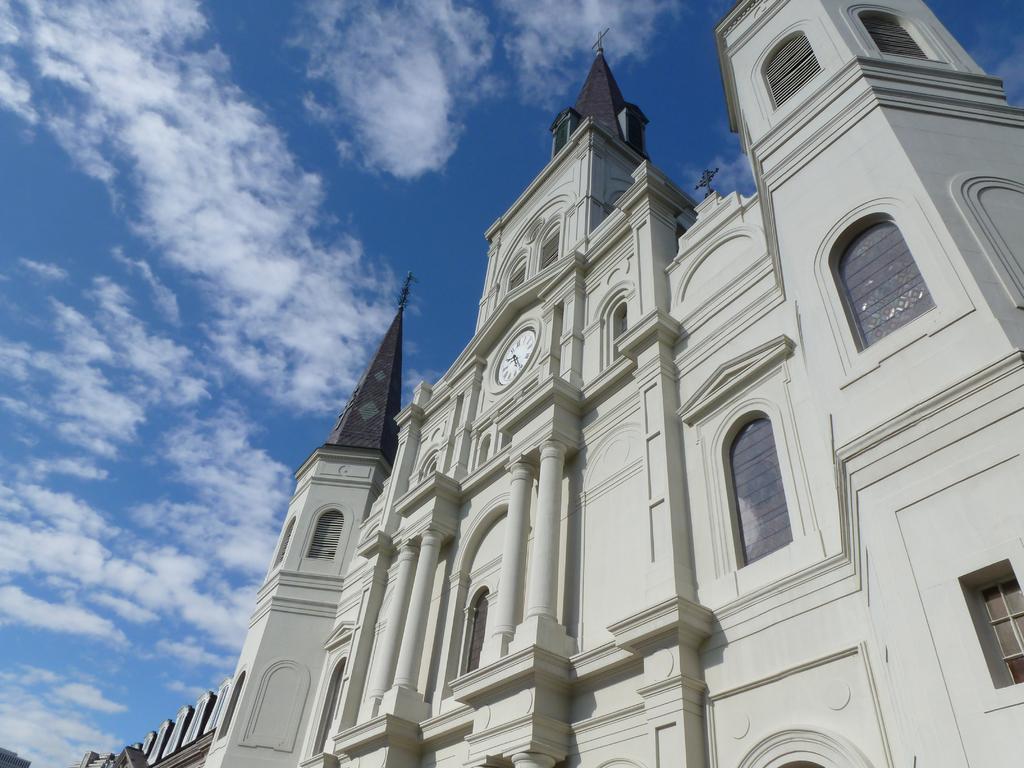Could you give a brief overview of what you see in this image? In this picture we can see the view of a tall building from the bottom & here the sky is blue. 